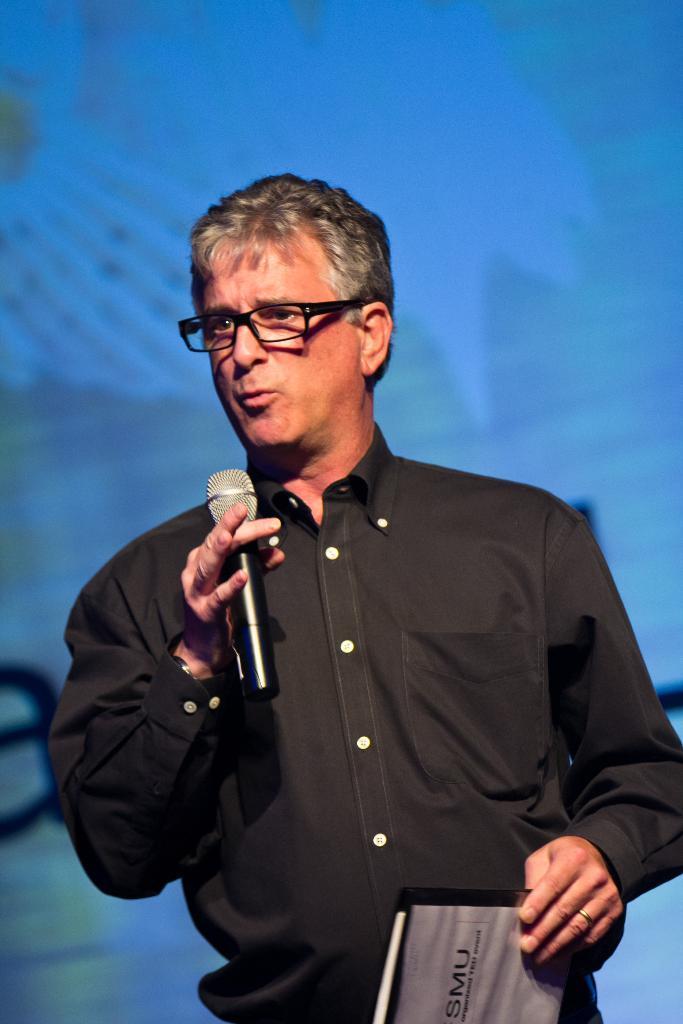How would you summarize this image in a sentence or two? In this picture we can see a person, he is holding a mic, book and wearing a spectacles and in the background we can see a screen. 